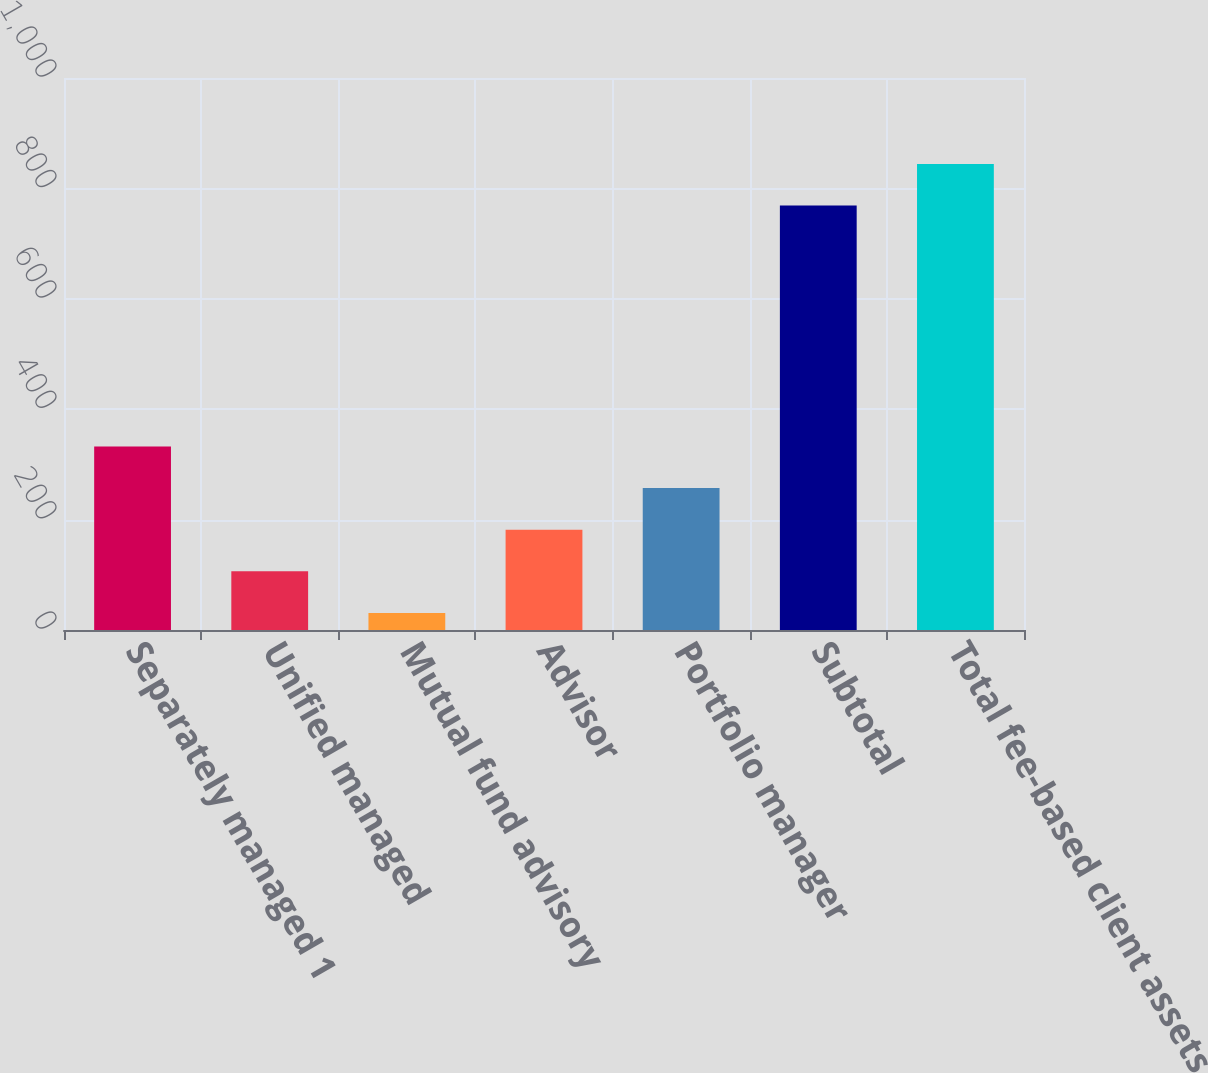Convert chart to OTSL. <chart><loc_0><loc_0><loc_500><loc_500><bar_chart><fcel>Separately managed 1<fcel>Unified managed<fcel>Mutual fund advisory<fcel>Advisor<fcel>Portfolio manager<fcel>Subtotal<fcel>Total fee-based client assets<nl><fcel>332.6<fcel>106.4<fcel>31<fcel>181.8<fcel>257.2<fcel>769<fcel>844.4<nl></chart> 